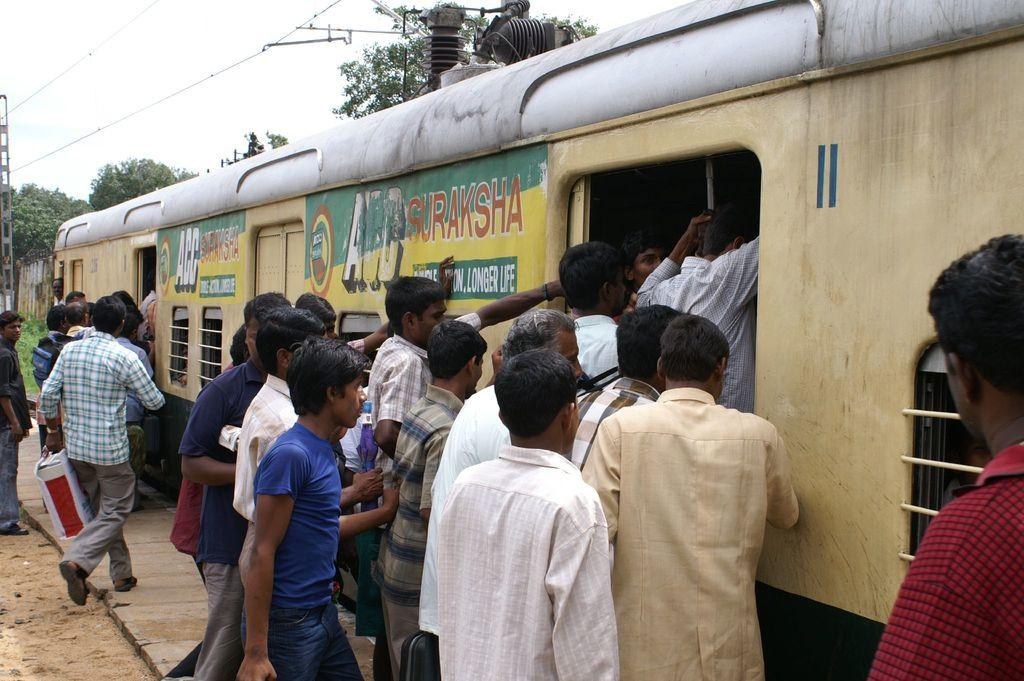What is happening with the group of people in the image? The people are entering a train in the image. What can be seen in the background of the image? Trees and the sky are visible at the top of the image. What type of donkey can be seen carrying luggage in the image? There is no donkey present in the image; the people are entering a train. 